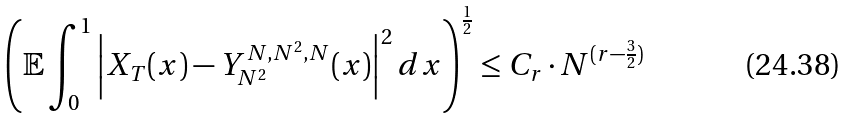Convert formula to latex. <formula><loc_0><loc_0><loc_500><loc_500>\left ( \mathbb { E } \int _ { 0 } ^ { 1 } \left | X _ { T } ( x ) - Y _ { N ^ { 2 } } ^ { N , N ^ { 2 } , N } ( x ) \right | ^ { 2 } d x \right ) ^ { \frac { 1 } { 2 } } \leq C _ { r } \cdot N ^ { ( r - \frac { 3 } { 2 } ) }</formula> 